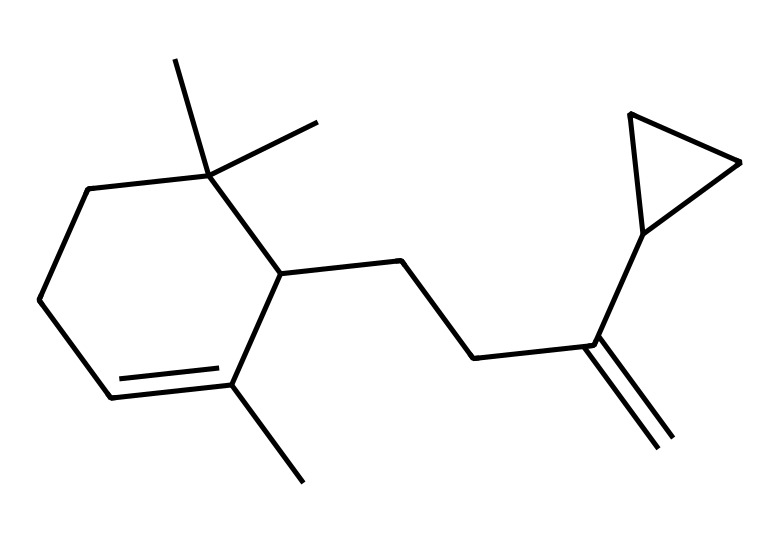How many carbon atoms are present in this caryophyllene structure? To determine the number of carbon atoms in caryophyllene, we need to count all the carbon symbols, which are represented by "C" in the provided SMILES. After inspecting the structure, we find a total of 15 carbon atoms.
Answer: 15 What type of structure does caryophyllene have? Caryophyllene has a cyclic structure as indicated by the presence of carbon atoms forming rings in the molecular arrangement. The notation "C1" and "C2" in the SMILES indicates the start of a ring structure, classifying it as cyclic.
Answer: cyclic How many double bonds are present in caryophyllene? By analyzing the SMILES, we can identify the locations of double bonds, particularly looking for instances such as "C=C." There is one double bond in the structure of caryophyllene which is noted in its chemistry.
Answer: 1 What functional group is predominantly featured in caryophyllene? Terpenes such as caryophyllene mainly consist of hydrocarbons, which means they have a predominance of carbon (C) and hydrogen (H) without major functional groups like alcohols or acids. This structure showcases only carbon and hydrogen, solidifying it as a hydrocarbon.
Answer: hydrocarbon Is caryophyllene a saturated or unsaturated compound? To determine if caryophyllene is saturated or unsaturated, we look for double bonds in the structure. The presence of a double bond indicates that the compound is unsaturated, meaning there are fewer hydrogen atoms relative to carbon than in a saturated compound.
Answer: unsaturated 